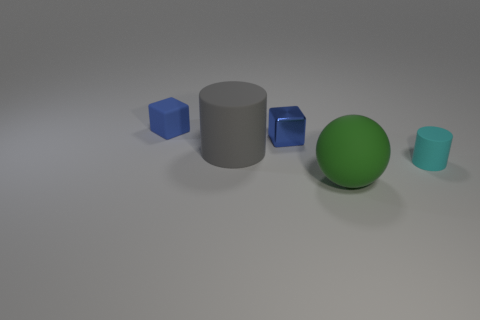Are there fewer tiny cyan cylinders behind the cyan matte cylinder than small red cylinders?
Ensure brevity in your answer.  No. What is the color of the metal cube?
Make the answer very short. Blue. Does the tiny rubber thing in front of the tiny blue matte thing have the same color as the metallic cube?
Keep it short and to the point. No. What color is the other big rubber object that is the same shape as the cyan thing?
Provide a short and direct response. Gray. What number of tiny objects are gray matte things or blue cubes?
Give a very brief answer. 2. There is a thing on the right side of the big green matte object; what is its size?
Your answer should be very brief. Small. Are there any big rubber cubes of the same color as the small metallic object?
Your answer should be compact. No. Does the sphere have the same color as the big cylinder?
Offer a terse response. No. The small matte object that is the same color as the shiny thing is what shape?
Ensure brevity in your answer.  Cube. What number of things are right of the object in front of the tiny cyan cylinder?
Your response must be concise. 1. 